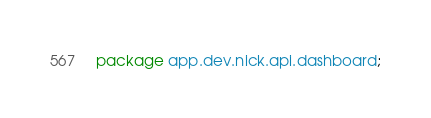<code> <loc_0><loc_0><loc_500><loc_500><_Java_>package app.dev.nick.api.dashboard;
</code> 